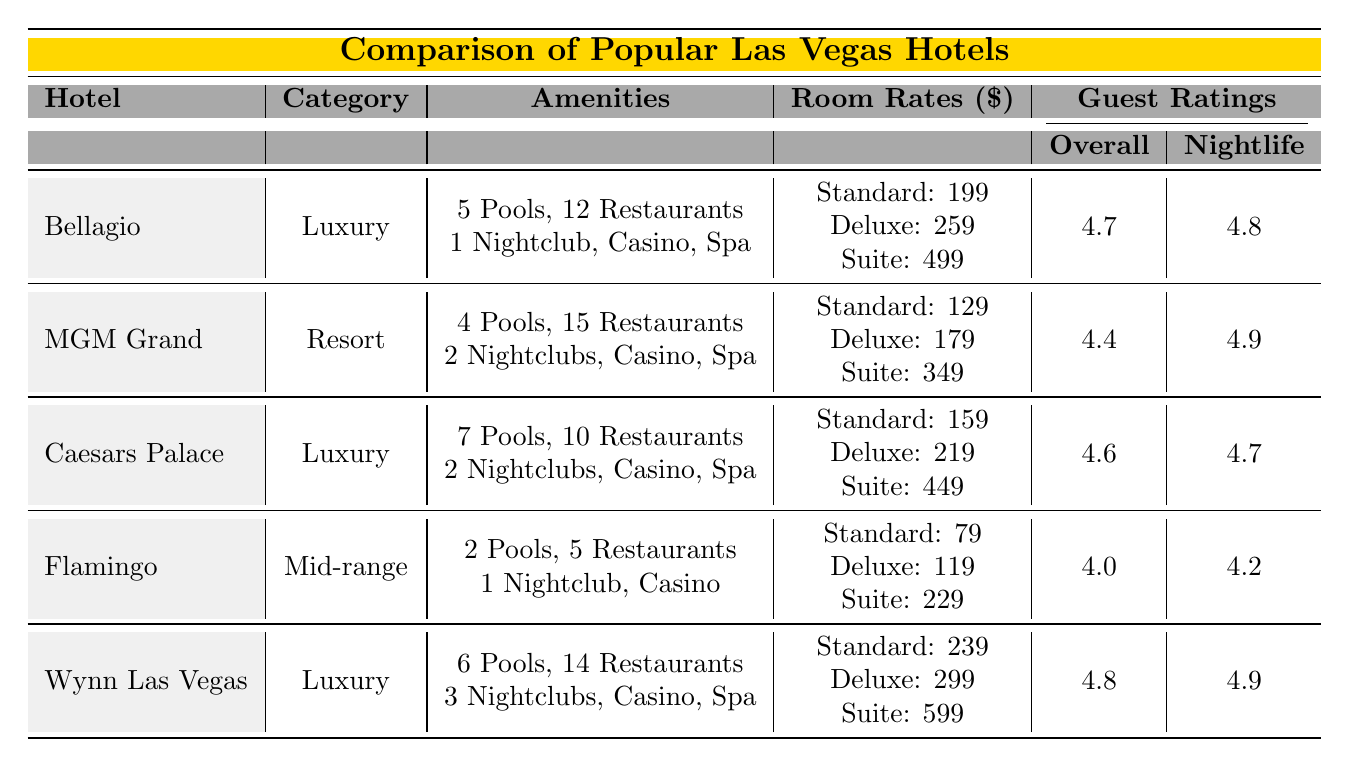What is the guest rating for the Bellagio? According to the table, the Overall guest rating for the Bellagio is listed under "Guest Ratings" as 4.7.
Answer: 4.7 How many nightclubs does Caesars Palace have? The table indicates that Caesars Palace has 2 nightclubs in the Amenities section.
Answer: 2 What is the price difference between a standard room at the MGM Grand and the Flamingo? The standard room rate at MGM Grand is 129, and the Flamingo is 79. The difference is 129 - 79 = 50.
Answer: 50 Which hotel has the highest overall guest rating? The table shows that Wynn Las Vegas has the highest Overall guest rating at 4.8, compared to others.
Answer: Wynn Las Vegas What is the average room rate for a deluxe room across all hotels? The deluxe room rates are: Bellagio 259, MGM Grand 179, Caesars Palace 219, Flamingo 119, and Wynn Las Vegas 299. The average is (259 + 179 + 219 + 119 + 299) / 5 = 215.
Answer: 215 Does the Flamingo have a spa? In the table, it is stated under Amenities that the Flamingo does not have a spa (false).
Answer: No Which hotel has the most pools, and how many? The table displays Caesars Palace with 7 pools, which is the highest number among all listed hotels.
Answer: Caesars Palace, 7 pools Which hotel offers the best value according to guest ratings? The value ratings for the hotels are: Bellagio 4.2, MGM Grand 4.3, Caesars Palace 4.1, Flamingo 4.5, and Wynn Las Vegas 4.0. MGM Grand has the highest value rating among them at 4.3.
Answer: MGM Grand What combination of amenities does Wynn Las Vegas offer? Wynn Las Vegas has 6 pools, 14 restaurants, 3 nightclubs, a casino, and a spa according to the Amenities section.
Answer: 6 pools, 14 restaurants, 3 nightclubs, casino, spa How does the room rate for a suite at the Bellagio compare to that at Wyn Las Vegas? The suite rate at Bellagio is 499, while at Wynn Las Vegas it is 599. The comparison shows that Bellagio is cheaper by 100.
Answer: Cheaper by 100 